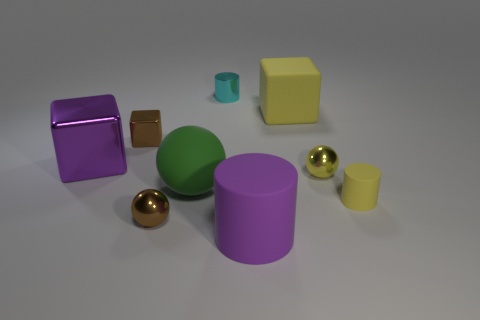Subtract all cylinders. How many objects are left? 6 Subtract all brown shiny blocks. Subtract all large yellow blocks. How many objects are left? 7 Add 7 tiny yellow shiny objects. How many tiny yellow shiny objects are left? 8 Add 4 green rubber blocks. How many green rubber blocks exist? 4 Subtract 0 blue cylinders. How many objects are left? 9 